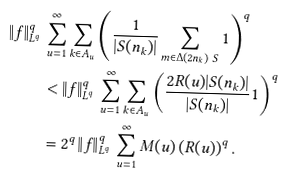Convert formula to latex. <formula><loc_0><loc_0><loc_500><loc_500>\left \| f \right \| _ { L ^ { q } } ^ { q } \, & \sum _ { u = 1 } ^ { \infty } \sum _ { k \in A _ { u } } \left ( \frac { 1 } { | S ( n _ { k } ) | } \sum _ { m \in \Delta ( 2 n _ { k } ) \ S } 1 \right ) ^ { q } \\ & < \left \| f \right \| _ { L ^ { q } } ^ { q } \, \sum _ { u = 1 } ^ { \infty } \sum _ { k \in A _ { u } } \left ( \frac { 2 R ( u ) | S ( n _ { k } ) | } { | S ( n _ { k } ) | } 1 \right ) ^ { q } \\ & = 2 ^ { q } \left \| f \right \| _ { L ^ { q } } ^ { q } \, \sum _ { u = 1 } ^ { \infty } M ( u ) \left ( R ( u ) \right ) ^ { q } .</formula> 